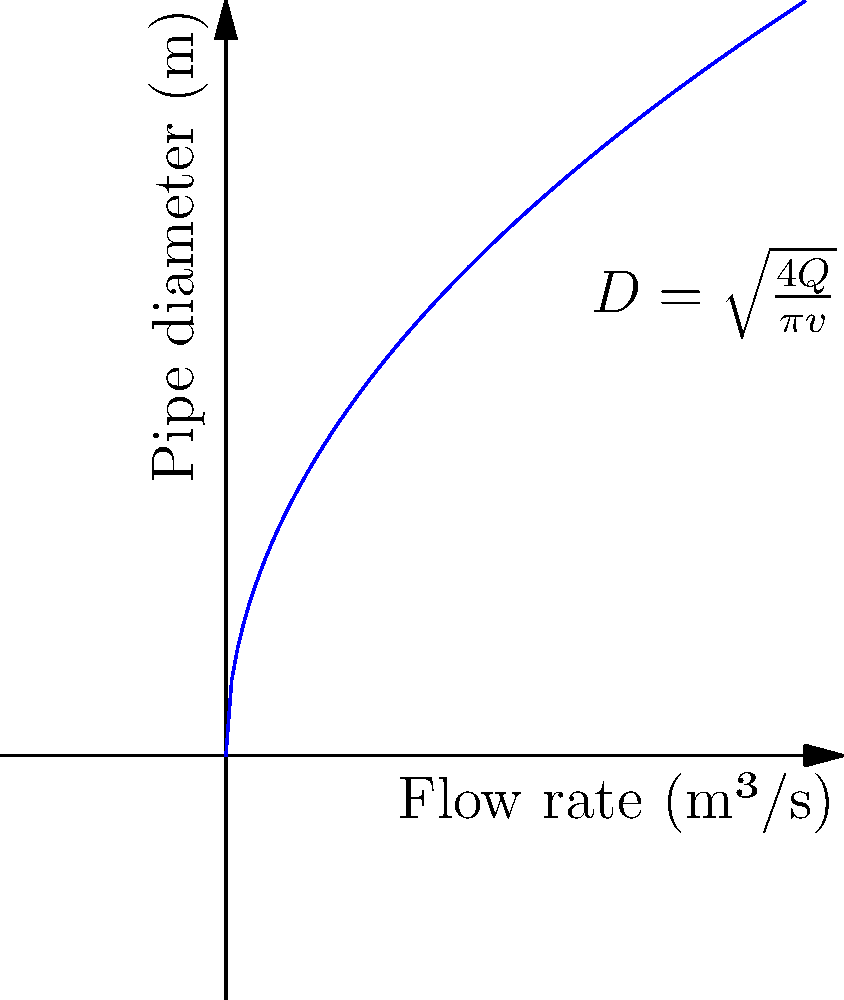As a mother teaching her children about responsible water usage, you want to explain how water systems work. If a community needs a water pipe with a flow rate of 0.2 m³/s and the water velocity should be 1.5 m/s, what diameter should the circular pipe have? Use the equation $D = \sqrt{\frac{4Q}{\pi v}}$, where D is the diameter, Q is the flow rate, and v is the velocity. To solve this problem, we'll use the given equation and follow these steps:

1. Identify the given values:
   Q (flow rate) = 0.2 m³/s
   v (velocity) = 1.5 m/s

2. Substitute these values into the equation:
   $D = \sqrt{\frac{4Q}{\pi v}}$
   $D = \sqrt{\frac{4 \times 0.2}{\pi \times 1.5}}$

3. Simplify the fraction inside the square root:
   $D = \sqrt{\frac{0.8}{\pi \times 1.5}}$
   $D = \sqrt{\frac{0.8}{1.5\pi}}$

4. Calculate the value under the square root:
   $D = \sqrt{0.1697}$

5. Take the square root to find the diameter:
   $D = 0.4119$ m

6. Round to two decimal places for practical purposes:
   $D \approx 0.41$ m

This diameter ensures that the water pipe can handle the required flow rate at the specified velocity, demonstrating efficient water management to your children.
Answer: 0.41 m 